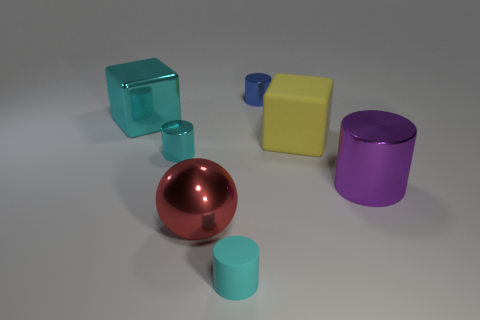Subtract all shiny cylinders. How many cylinders are left? 1 Subtract all cyan cylinders. How many cylinders are left? 2 Add 2 big cyan blocks. How many objects exist? 9 Subtract all cubes. How many objects are left? 5 Subtract 1 blocks. How many blocks are left? 1 Subtract all red cylinders. Subtract all red cubes. How many cylinders are left? 4 Subtract all brown blocks. How many blue balls are left? 0 Subtract all small blue metallic cubes. Subtract all big metallic cubes. How many objects are left? 6 Add 4 metallic cylinders. How many metallic cylinders are left? 7 Add 6 big red matte cubes. How many big red matte cubes exist? 6 